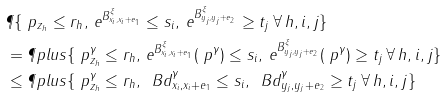Convert formula to latex. <formula><loc_0><loc_0><loc_500><loc_500>& \P \{ \ p _ { z _ { h } } \leq r _ { h } , \, e ^ { B ^ { \xi } _ { x _ { i } , x _ { i } + e _ { 1 } } } \leq s _ { i } , \, e ^ { B ^ { \xi } _ { y _ { j } , y _ { j } + e _ { 2 } } } \geq t _ { j } \, \forall \, h , i , j \} \\ & = \P p l u s \{ \ p ^ { \gamma } _ { z _ { h } } \leq r _ { h } , \, e ^ { B ^ { \xi } _ { x _ { i } , x _ { i } + e _ { 1 } } } ( \ p ^ { \gamma } ) \leq s _ { i } , \, e ^ { B ^ { \xi } _ { y _ { j } , y _ { j } + e _ { 2 } } } ( \ p ^ { \gamma } ) \geq t _ { j } \, \forall \, h , i , j \} \\ & \leq \P p l u s \{ \ p ^ { \gamma } _ { z _ { h } } \leq r _ { h } , \, \ B d ^ { \gamma } _ { x _ { i } , x _ { i } + e _ { 1 } } \leq s _ { i } , \, \ B d ^ { \gamma } _ { y _ { j } , y _ { j } + e _ { 2 } } \geq t _ { j } \, \forall \, h , i , j \}</formula> 